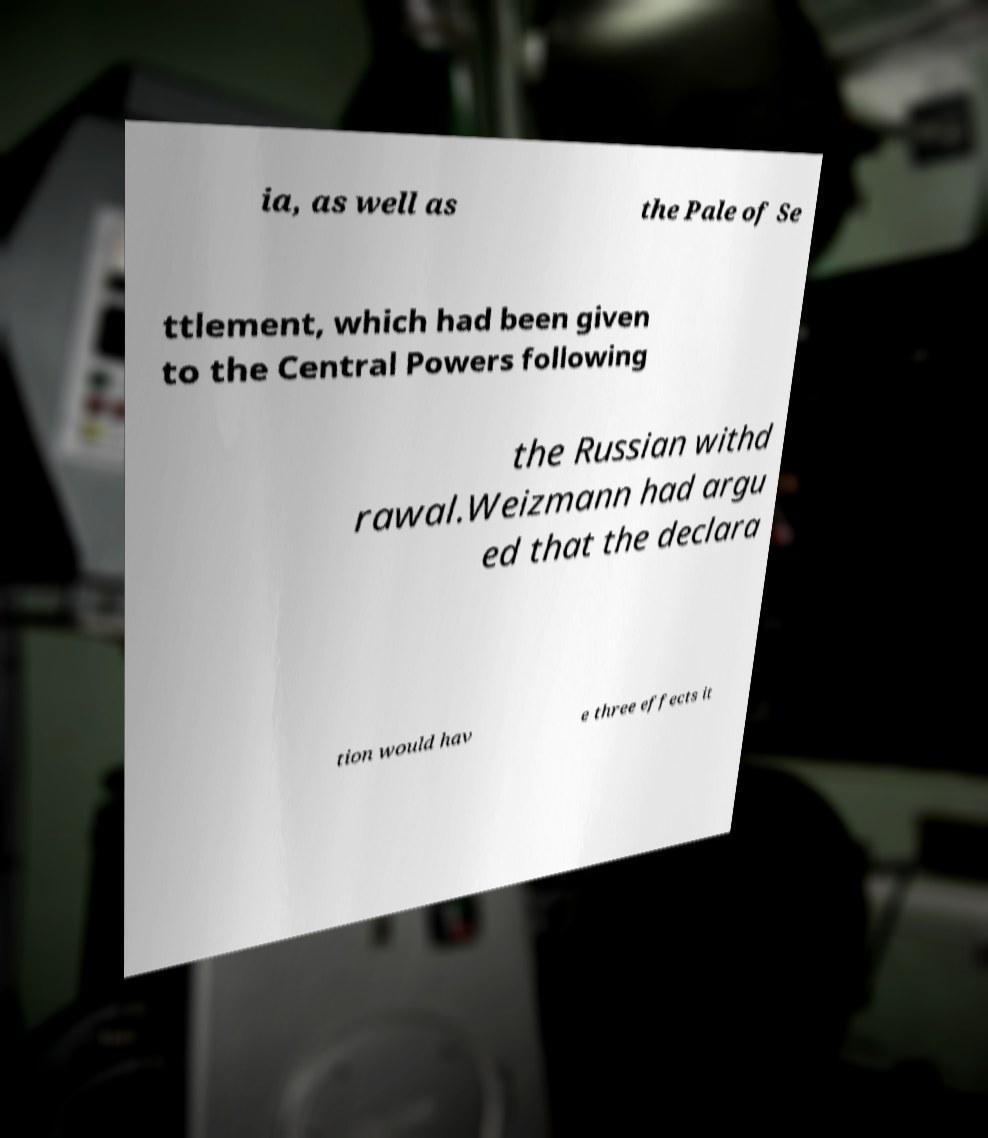There's text embedded in this image that I need extracted. Can you transcribe it verbatim? ia, as well as the Pale of Se ttlement, which had been given to the Central Powers following the Russian withd rawal.Weizmann had argu ed that the declara tion would hav e three effects it 